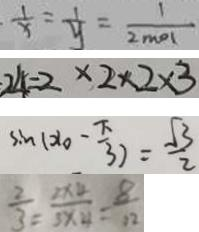Convert formula to latex. <formula><loc_0><loc_0><loc_500><loc_500>\frac { 1 } { x } = \frac { 1 } { y } = \frac { 1 } { 2 m o l } 
 2 4 = 2 \times 2 \times 2 \times 3 
 \sin ( x _ { 0 } - \frac { \pi } { 3 } ) = \frac { \sqrt { 3 } } { 2 } 
 \frac { 2 } { 3 } = \frac { 2 \times 4 } { 3 \times 4 } = \frac { 8 } { 1 2 }</formula> 